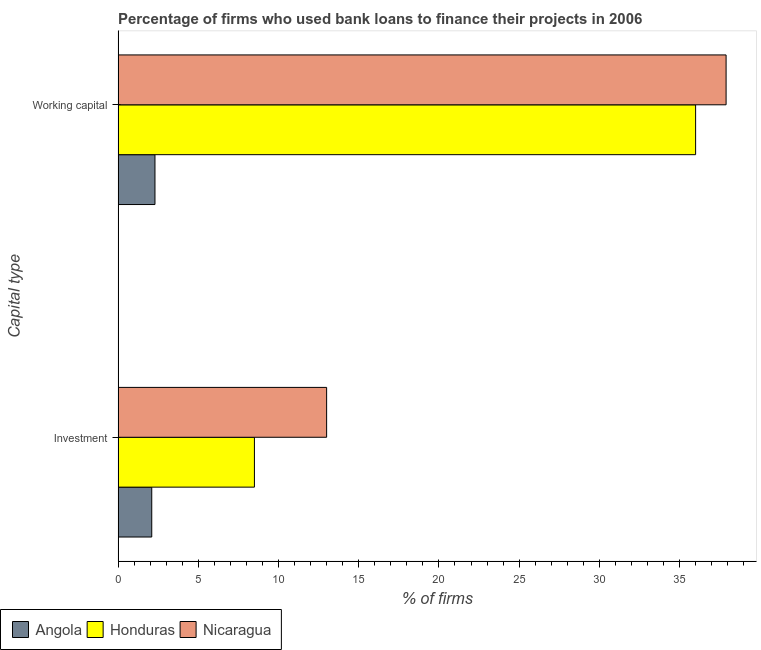How many different coloured bars are there?
Keep it short and to the point. 3. Are the number of bars per tick equal to the number of legend labels?
Ensure brevity in your answer.  Yes. How many bars are there on the 2nd tick from the top?
Provide a succinct answer. 3. How many bars are there on the 2nd tick from the bottom?
Give a very brief answer. 3. What is the label of the 2nd group of bars from the top?
Keep it short and to the point. Investment. Across all countries, what is the maximum percentage of firms using banks to finance investment?
Your answer should be very brief. 13. In which country was the percentage of firms using banks to finance working capital maximum?
Make the answer very short. Nicaragua. In which country was the percentage of firms using banks to finance working capital minimum?
Offer a very short reply. Angola. What is the total percentage of firms using banks to finance investment in the graph?
Make the answer very short. 23.6. What is the difference between the percentage of firms using banks to finance working capital in Honduras and that in Angola?
Provide a succinct answer. 33.7. What is the difference between the percentage of firms using banks to finance working capital in Nicaragua and the percentage of firms using banks to finance investment in Honduras?
Your response must be concise. 29.4. What is the average percentage of firms using banks to finance investment per country?
Ensure brevity in your answer.  7.87. What is the difference between the percentage of firms using banks to finance investment and percentage of firms using banks to finance working capital in Nicaragua?
Offer a very short reply. -24.9. What is the ratio of the percentage of firms using banks to finance investment in Nicaragua to that in Angola?
Ensure brevity in your answer.  6.19. In how many countries, is the percentage of firms using banks to finance working capital greater than the average percentage of firms using banks to finance working capital taken over all countries?
Your answer should be compact. 2. What does the 2nd bar from the top in Investment represents?
Offer a terse response. Honduras. What does the 1st bar from the bottom in Working capital represents?
Provide a short and direct response. Angola. How many bars are there?
Give a very brief answer. 6. Are all the bars in the graph horizontal?
Provide a short and direct response. Yes. How many countries are there in the graph?
Ensure brevity in your answer.  3. What is the difference between two consecutive major ticks on the X-axis?
Give a very brief answer. 5. Does the graph contain grids?
Ensure brevity in your answer.  No. Where does the legend appear in the graph?
Ensure brevity in your answer.  Bottom left. How are the legend labels stacked?
Offer a terse response. Horizontal. What is the title of the graph?
Provide a succinct answer. Percentage of firms who used bank loans to finance their projects in 2006. Does "St. Lucia" appear as one of the legend labels in the graph?
Ensure brevity in your answer.  No. What is the label or title of the X-axis?
Your answer should be compact. % of firms. What is the label or title of the Y-axis?
Offer a very short reply. Capital type. What is the % of firms of Honduras in Investment?
Offer a terse response. 8.5. What is the % of firms in Nicaragua in Investment?
Your response must be concise. 13. What is the % of firms of Angola in Working capital?
Keep it short and to the point. 2.3. What is the % of firms of Honduras in Working capital?
Your answer should be very brief. 36. What is the % of firms of Nicaragua in Working capital?
Provide a succinct answer. 37.9. Across all Capital type, what is the maximum % of firms of Angola?
Provide a succinct answer. 2.3. Across all Capital type, what is the maximum % of firms of Nicaragua?
Your response must be concise. 37.9. Across all Capital type, what is the minimum % of firms of Honduras?
Make the answer very short. 8.5. What is the total % of firms of Angola in the graph?
Ensure brevity in your answer.  4.4. What is the total % of firms in Honduras in the graph?
Your response must be concise. 44.5. What is the total % of firms of Nicaragua in the graph?
Your answer should be very brief. 50.9. What is the difference between the % of firms in Angola in Investment and that in Working capital?
Offer a terse response. -0.2. What is the difference between the % of firms of Honduras in Investment and that in Working capital?
Your response must be concise. -27.5. What is the difference between the % of firms in Nicaragua in Investment and that in Working capital?
Your answer should be compact. -24.9. What is the difference between the % of firms of Angola in Investment and the % of firms of Honduras in Working capital?
Provide a succinct answer. -33.9. What is the difference between the % of firms in Angola in Investment and the % of firms in Nicaragua in Working capital?
Offer a terse response. -35.8. What is the difference between the % of firms in Honduras in Investment and the % of firms in Nicaragua in Working capital?
Your response must be concise. -29.4. What is the average % of firms in Angola per Capital type?
Provide a short and direct response. 2.2. What is the average % of firms in Honduras per Capital type?
Your answer should be compact. 22.25. What is the average % of firms of Nicaragua per Capital type?
Provide a succinct answer. 25.45. What is the difference between the % of firms in Angola and % of firms in Nicaragua in Investment?
Make the answer very short. -10.9. What is the difference between the % of firms of Angola and % of firms of Honduras in Working capital?
Provide a succinct answer. -33.7. What is the difference between the % of firms of Angola and % of firms of Nicaragua in Working capital?
Your answer should be very brief. -35.6. What is the ratio of the % of firms of Honduras in Investment to that in Working capital?
Your response must be concise. 0.24. What is the ratio of the % of firms of Nicaragua in Investment to that in Working capital?
Make the answer very short. 0.34. What is the difference between the highest and the second highest % of firms in Nicaragua?
Offer a very short reply. 24.9. What is the difference between the highest and the lowest % of firms in Angola?
Provide a short and direct response. 0.2. What is the difference between the highest and the lowest % of firms of Nicaragua?
Your answer should be very brief. 24.9. 